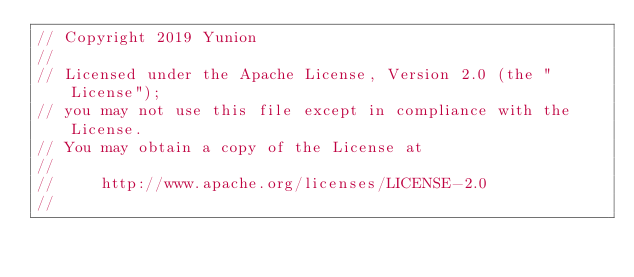Convert code to text. <code><loc_0><loc_0><loc_500><loc_500><_Go_>// Copyright 2019 Yunion
//
// Licensed under the Apache License, Version 2.0 (the "License");
// you may not use this file except in compliance with the License.
// You may obtain a copy of the License at
//
//     http://www.apache.org/licenses/LICENSE-2.0
//</code> 